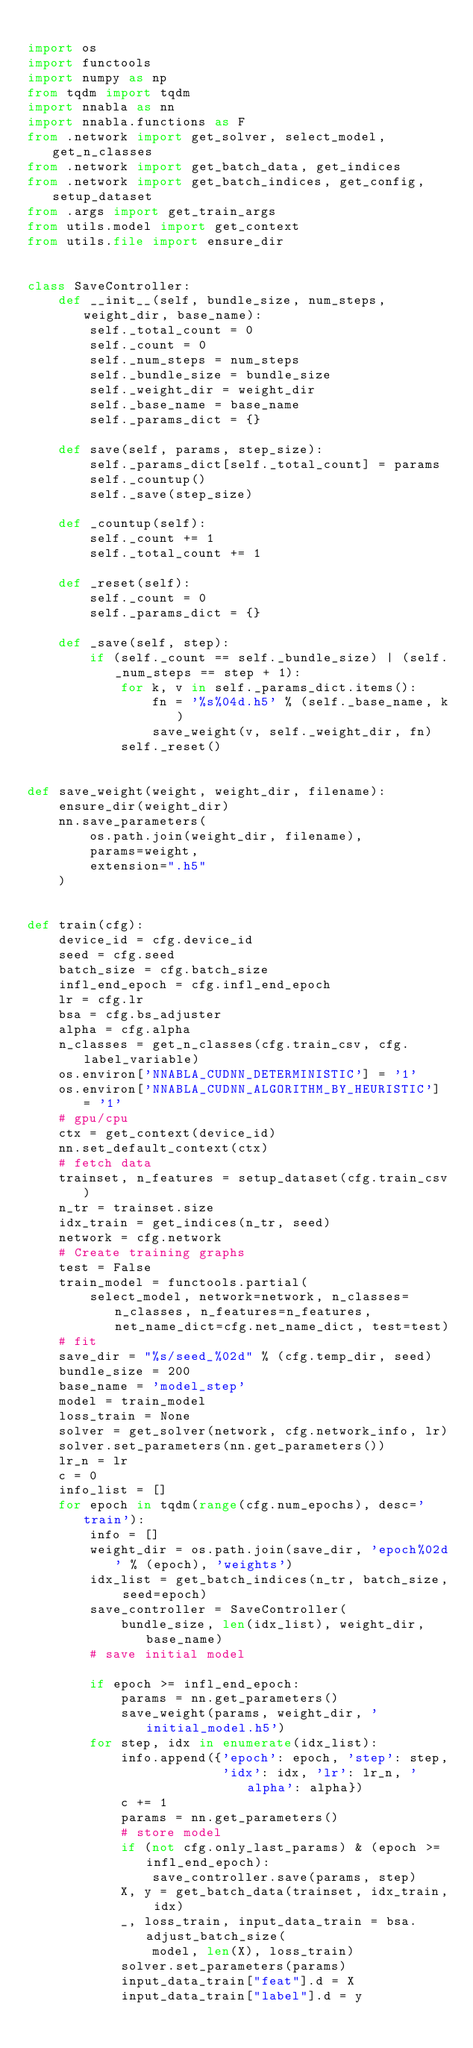Convert code to text. <code><loc_0><loc_0><loc_500><loc_500><_Python_>
import os
import functools
import numpy as np
from tqdm import tqdm
import nnabla as nn
import nnabla.functions as F
from .network import get_solver, select_model, get_n_classes
from .network import get_batch_data, get_indices
from .network import get_batch_indices, get_config, setup_dataset
from .args import get_train_args
from utils.model import get_context
from utils.file import ensure_dir


class SaveController:
    def __init__(self, bundle_size, num_steps, weight_dir, base_name):
        self._total_count = 0
        self._count = 0
        self._num_steps = num_steps
        self._bundle_size = bundle_size
        self._weight_dir = weight_dir
        self._base_name = base_name
        self._params_dict = {}

    def save(self, params, step_size):
        self._params_dict[self._total_count] = params
        self._countup()
        self._save(step_size)

    def _countup(self):
        self._count += 1
        self._total_count += 1

    def _reset(self):
        self._count = 0
        self._params_dict = {}

    def _save(self, step):
        if (self._count == self._bundle_size) | (self._num_steps == step + 1):
            for k, v in self._params_dict.items():
                fn = '%s%04d.h5' % (self._base_name, k)
                save_weight(v, self._weight_dir, fn)
            self._reset()


def save_weight(weight, weight_dir, filename):
    ensure_dir(weight_dir)
    nn.save_parameters(
        os.path.join(weight_dir, filename),
        params=weight,
        extension=".h5"
    )


def train(cfg):
    device_id = cfg.device_id
    seed = cfg.seed
    batch_size = cfg.batch_size
    infl_end_epoch = cfg.infl_end_epoch
    lr = cfg.lr
    bsa = cfg.bs_adjuster
    alpha = cfg.alpha
    n_classes = get_n_classes(cfg.train_csv, cfg.label_variable)
    os.environ['NNABLA_CUDNN_DETERMINISTIC'] = '1'
    os.environ['NNABLA_CUDNN_ALGORITHM_BY_HEURISTIC'] = '1'
    # gpu/cpu
    ctx = get_context(device_id)
    nn.set_default_context(ctx)
    # fetch data
    trainset, n_features = setup_dataset(cfg.train_csv)
    n_tr = trainset.size
    idx_train = get_indices(n_tr, seed)
    network = cfg.network
    # Create training graphs
    test = False
    train_model = functools.partial(
        select_model, network=network, n_classes=n_classes, n_features=n_features, net_name_dict=cfg.net_name_dict, test=test)
    # fit
    save_dir = "%s/seed_%02d" % (cfg.temp_dir, seed)
    bundle_size = 200
    base_name = 'model_step'
    model = train_model
    loss_train = None
    solver = get_solver(network, cfg.network_info, lr)
    solver.set_parameters(nn.get_parameters())
    lr_n = lr
    c = 0
    info_list = []
    for epoch in tqdm(range(cfg.num_epochs), desc='train'):
        info = []
        weight_dir = os.path.join(save_dir, 'epoch%02d' % (epoch), 'weights')
        idx_list = get_batch_indices(n_tr, batch_size, seed=epoch)
        save_controller = SaveController(
            bundle_size, len(idx_list), weight_dir, base_name)
        # save initial model

        if epoch >= infl_end_epoch:
            params = nn.get_parameters()
            save_weight(params, weight_dir, 'initial_model.h5')
        for step, idx in enumerate(idx_list):
            info.append({'epoch': epoch, 'step': step,
                         'idx': idx, 'lr': lr_n, 'alpha': alpha})
            c += 1
            params = nn.get_parameters()
            # store model
            if (not cfg.only_last_params) & (epoch >= infl_end_epoch):
                save_controller.save(params, step)
            X, y = get_batch_data(trainset, idx_train, idx)
            _, loss_train, input_data_train = bsa.adjust_batch_size(
                model, len(X), loss_train)
            solver.set_parameters(params)
            input_data_train["feat"].d = X
            input_data_train["label"].d = y
</code> 